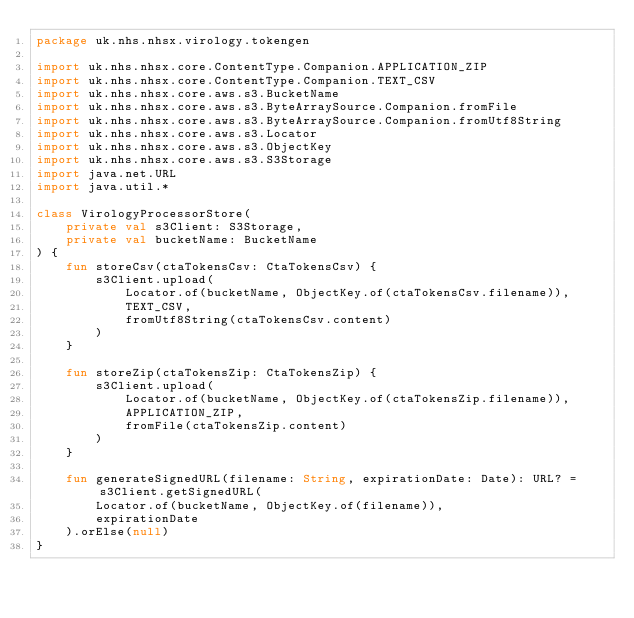Convert code to text. <code><loc_0><loc_0><loc_500><loc_500><_Kotlin_>package uk.nhs.nhsx.virology.tokengen

import uk.nhs.nhsx.core.ContentType.Companion.APPLICATION_ZIP
import uk.nhs.nhsx.core.ContentType.Companion.TEXT_CSV
import uk.nhs.nhsx.core.aws.s3.BucketName
import uk.nhs.nhsx.core.aws.s3.ByteArraySource.Companion.fromFile
import uk.nhs.nhsx.core.aws.s3.ByteArraySource.Companion.fromUtf8String
import uk.nhs.nhsx.core.aws.s3.Locator
import uk.nhs.nhsx.core.aws.s3.ObjectKey
import uk.nhs.nhsx.core.aws.s3.S3Storage
import java.net.URL
import java.util.*

class VirologyProcessorStore(
    private val s3Client: S3Storage,
    private val bucketName: BucketName
) {
    fun storeCsv(ctaTokensCsv: CtaTokensCsv) {
        s3Client.upload(
            Locator.of(bucketName, ObjectKey.of(ctaTokensCsv.filename)),
            TEXT_CSV,
            fromUtf8String(ctaTokensCsv.content)
        )
    }

    fun storeZip(ctaTokensZip: CtaTokensZip) {
        s3Client.upload(
            Locator.of(bucketName, ObjectKey.of(ctaTokensZip.filename)),
            APPLICATION_ZIP,
            fromFile(ctaTokensZip.content)
        )
    }

    fun generateSignedURL(filename: String, expirationDate: Date): URL? = s3Client.getSignedURL(
        Locator.of(bucketName, ObjectKey.of(filename)),
        expirationDate
    ).orElse(null)
}
</code> 